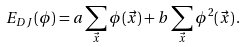<formula> <loc_0><loc_0><loc_500><loc_500>E _ { D J } ( \phi ) = a \sum _ { \vec { x } } \phi ( \vec { x } ) + b \sum _ { \vec { x } } \phi ^ { 2 } ( \vec { x } ) \, .</formula> 